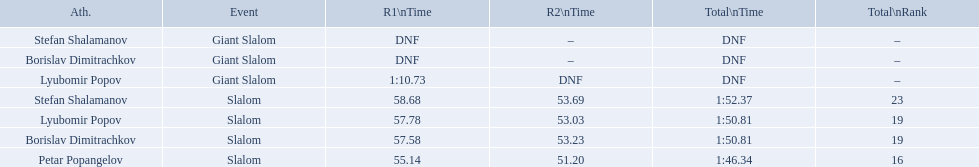What are all the competitions lyubomir popov competed in? Lyubomir Popov, Lyubomir Popov. Of those, which were giant slalom races? Giant Slalom. What was his time in race 1? 1:10.73. Which event is the giant slalom? Giant Slalom, Giant Slalom, Giant Slalom. Which one is lyubomir popov? Lyubomir Popov. What is race 1 tim? 1:10.73. 